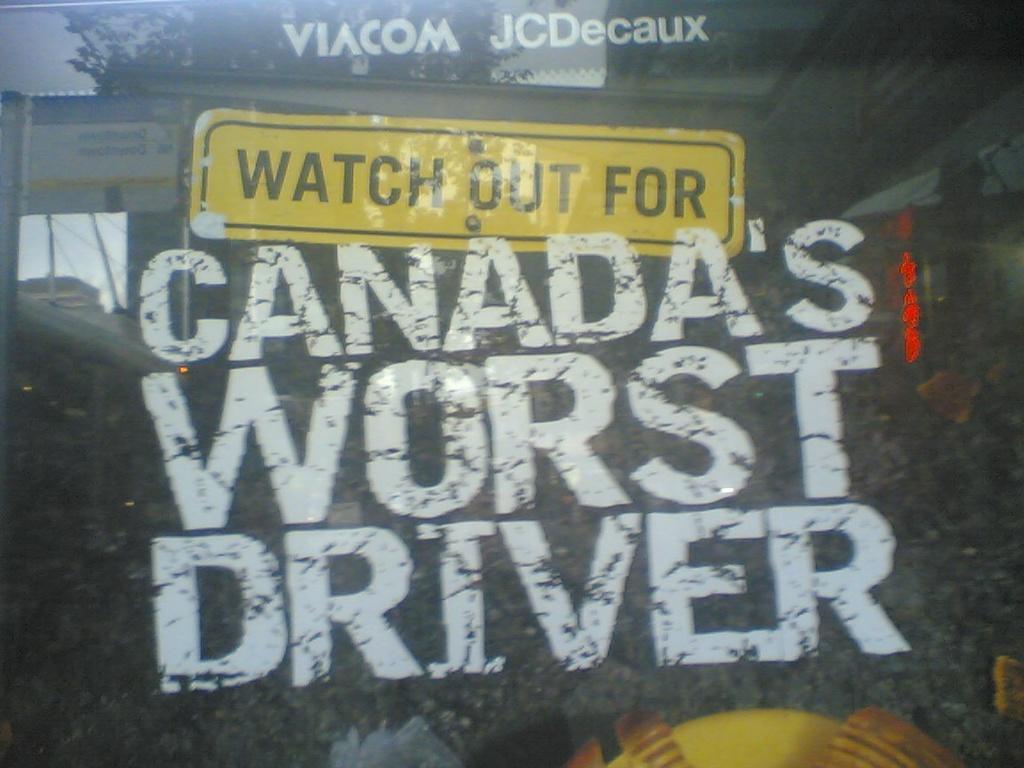In one or two sentences, can you explain what this image depicts? In the image we can see a glass window, on the window there is a poster. 